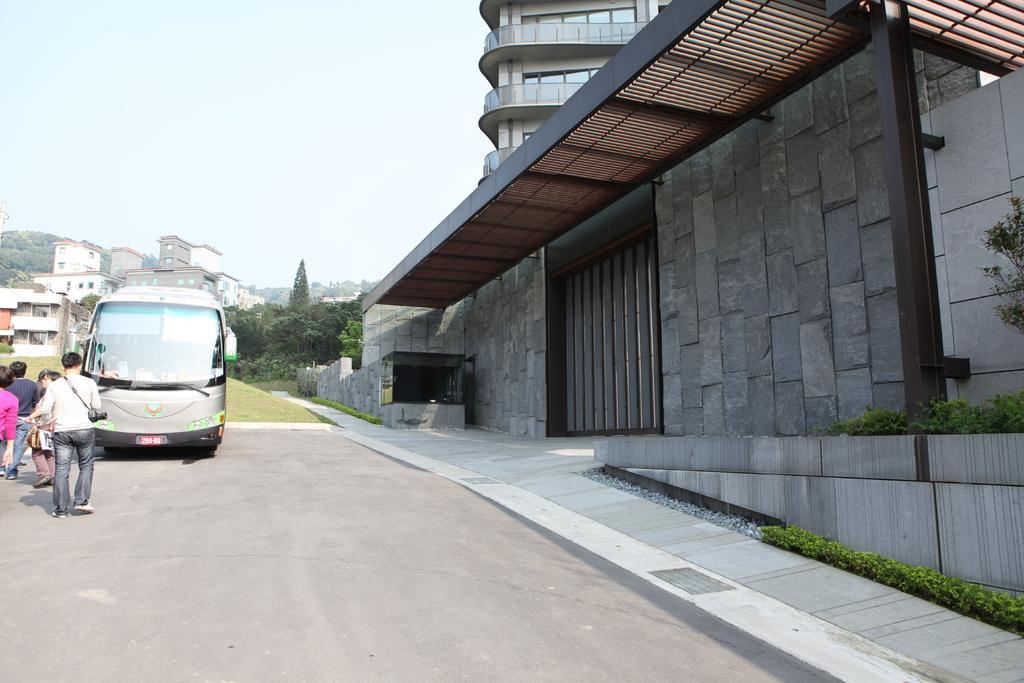Could you give a brief overview of what you see in this image? There are buildings, there is vehicle, here people are walking, there are trees. 